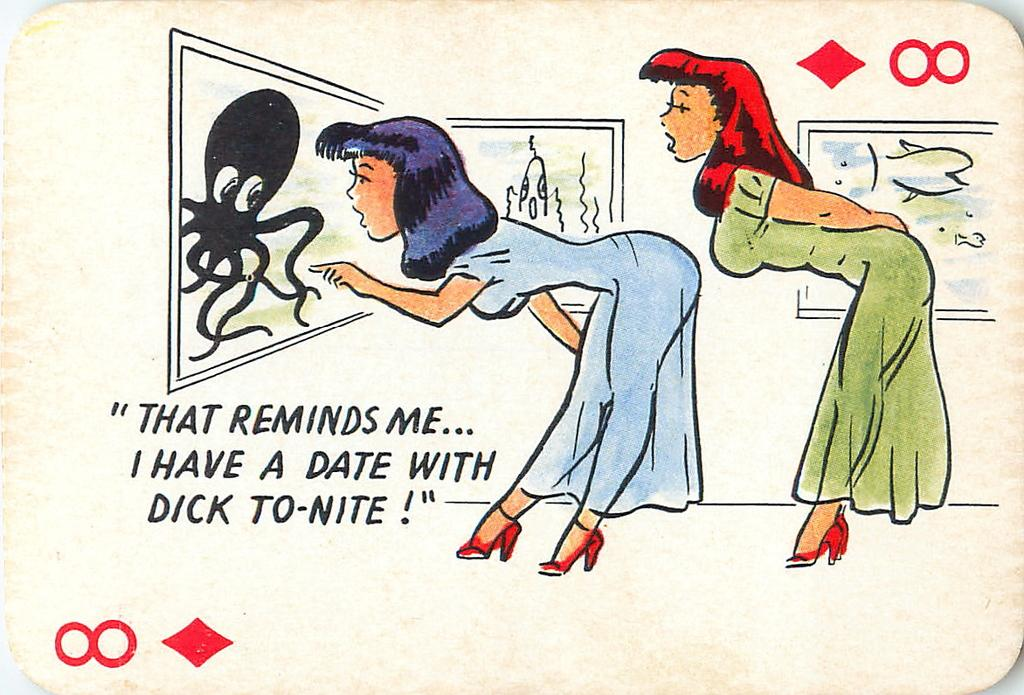What can be found in the foreground of the image? In the foreground of the image, there is text, digits, symbols, frames, and two women. Can you describe the text in the foreground? The text in the foreground consists of letters and words. What are the digits in the foreground? The digits in the foreground are numbers. What do the symbols in the foreground represent? The symbols in the foreground could represent various things, such as mathematical operations or punctuation marks. How many women are in the foreground of the image? There are two women in the foreground of the image. How many pizzas are being served to the women in the image? There are no pizzas present in the image. What is the amount of debt the women are discussing in the image? There is no indication of a discussion about debt in the image. Can you describe the rabbit that is sitting next to the women in the image? There is no rabbit present in the image. 